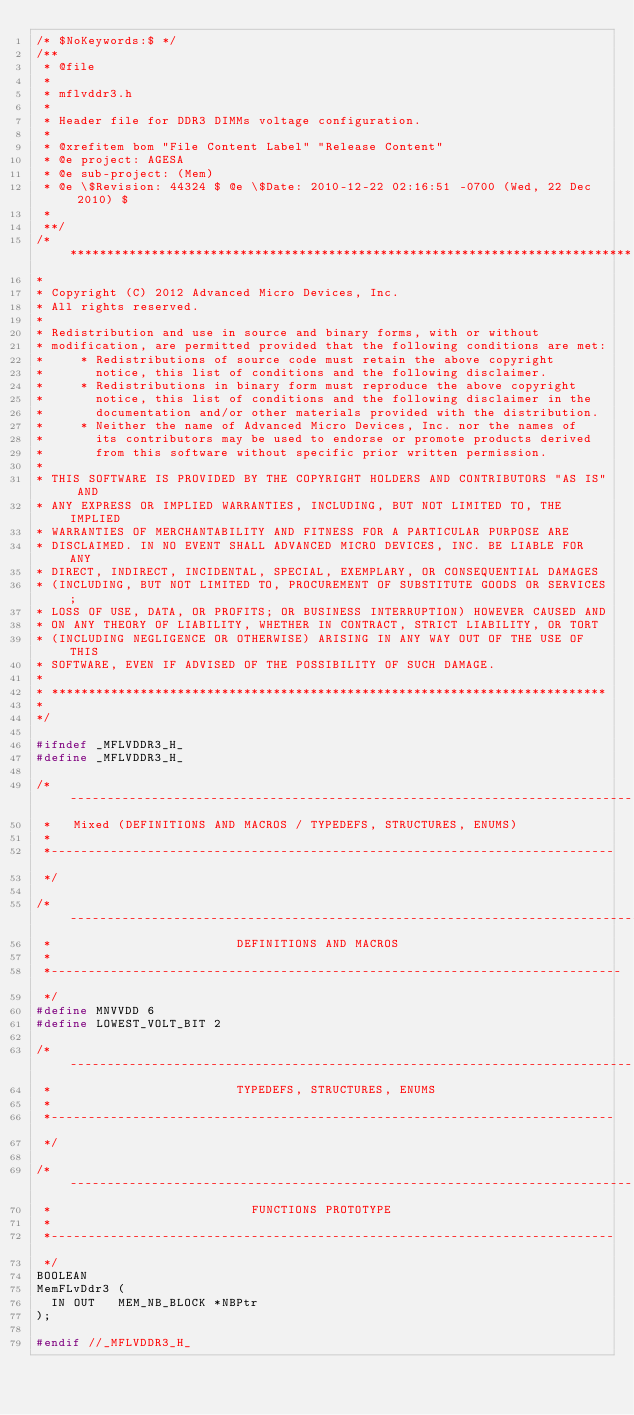Convert code to text. <code><loc_0><loc_0><loc_500><loc_500><_C_>/* $NoKeywords:$ */
/**
 * @file
 *
 * mflvddr3.h
 *
 * Header file for DDR3 DIMMs voltage configuration.
 *
 * @xrefitem bom "File Content Label" "Release Content"
 * @e project: AGESA
 * @e sub-project: (Mem)
 * @e \$Revision: 44324 $ @e \$Date: 2010-12-22 02:16:51 -0700 (Wed, 22 Dec 2010) $
 *
 **/
/*****************************************************************************
*
* Copyright (C) 2012 Advanced Micro Devices, Inc.
* All rights reserved.
*
* Redistribution and use in source and binary forms, with or without
* modification, are permitted provided that the following conditions are met:
*     * Redistributions of source code must retain the above copyright
*       notice, this list of conditions and the following disclaimer.
*     * Redistributions in binary form must reproduce the above copyright
*       notice, this list of conditions and the following disclaimer in the
*       documentation and/or other materials provided with the distribution.
*     * Neither the name of Advanced Micro Devices, Inc. nor the names of
*       its contributors may be used to endorse or promote products derived
*       from this software without specific prior written permission.
*
* THIS SOFTWARE IS PROVIDED BY THE COPYRIGHT HOLDERS AND CONTRIBUTORS "AS IS" AND
* ANY EXPRESS OR IMPLIED WARRANTIES, INCLUDING, BUT NOT LIMITED TO, THE IMPLIED
* WARRANTIES OF MERCHANTABILITY AND FITNESS FOR A PARTICULAR PURPOSE ARE
* DISCLAIMED. IN NO EVENT SHALL ADVANCED MICRO DEVICES, INC. BE LIABLE FOR ANY
* DIRECT, INDIRECT, INCIDENTAL, SPECIAL, EXEMPLARY, OR CONSEQUENTIAL DAMAGES
* (INCLUDING, BUT NOT LIMITED TO, PROCUREMENT OF SUBSTITUTE GOODS OR SERVICES;
* LOSS OF USE, DATA, OR PROFITS; OR BUSINESS INTERRUPTION) HOWEVER CAUSED AND
* ON ANY THEORY OF LIABILITY, WHETHER IN CONTRACT, STRICT LIABILITY, OR TORT
* (INCLUDING NEGLIGENCE OR OTHERWISE) ARISING IN ANY WAY OUT OF THE USE OF THIS
* SOFTWARE, EVEN IF ADVISED OF THE POSSIBILITY OF SUCH DAMAGE.
*
* ***************************************************************************
*
*/

#ifndef _MFLVDDR3_H_
#define _MFLVDDR3_H_

/*----------------------------------------------------------------------------
 *   Mixed (DEFINITIONS AND MACROS / TYPEDEFS, STRUCTURES, ENUMS)
 *
 *----------------------------------------------------------------------------
 */

/*-----------------------------------------------------------------------------
 *                         DEFINITIONS AND MACROS
 *
 *-----------------------------------------------------------------------------
 */
#define MNVVDD 6
#define LOWEST_VOLT_BIT 2

/*----------------------------------------------------------------------------
 *                         TYPEDEFS, STRUCTURES, ENUMS
 *
 *----------------------------------------------------------------------------
 */

/*----------------------------------------------------------------------------
 *                           FUNCTIONS PROTOTYPE
 *
 *----------------------------------------------------------------------------
 */
BOOLEAN
MemFLvDdr3 (
  IN OUT   MEM_NB_BLOCK *NBPtr
);

#endif //_MFLVDDR3_H_
</code> 